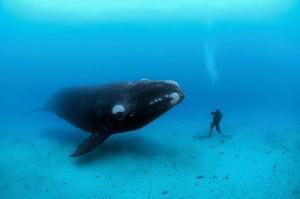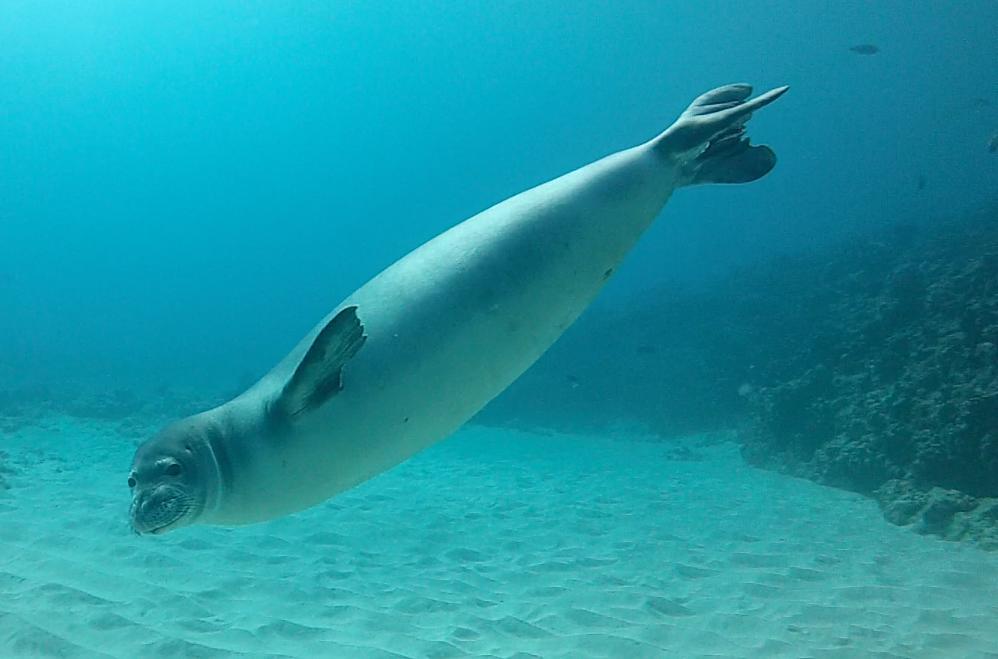The first image is the image on the left, the second image is the image on the right. Examine the images to the left and right. Is the description "There is one person on the ocean floor." accurate? Answer yes or no. Yes. 